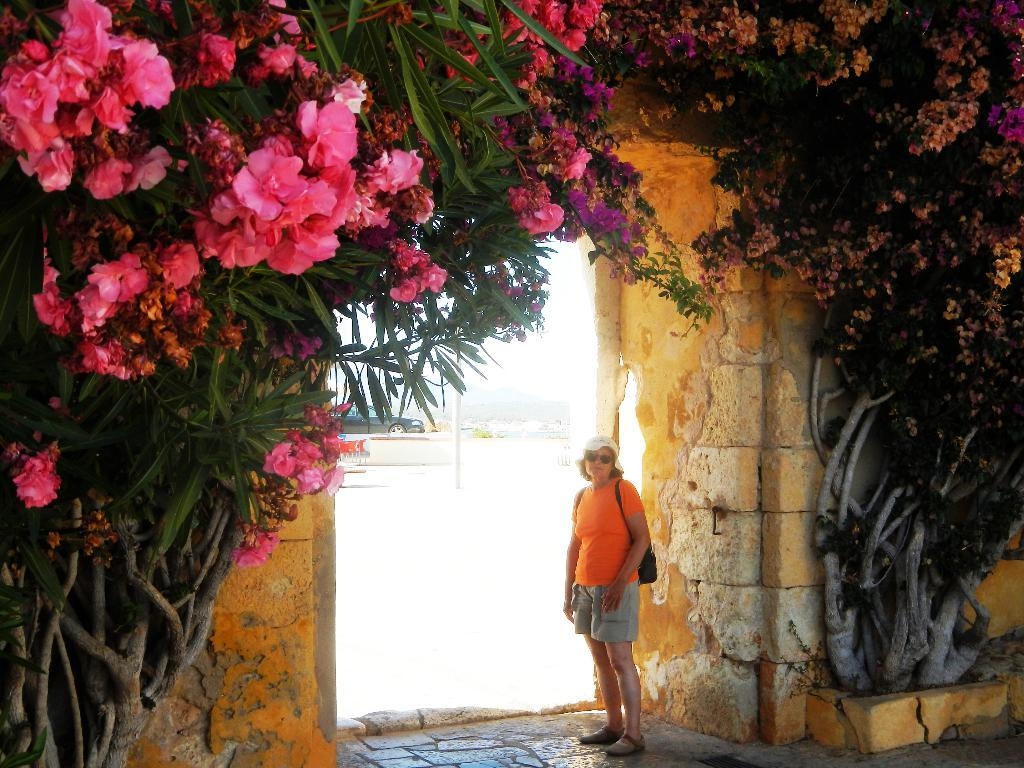What is the primary subject of the image? There is a woman in the image. What is the woman doing in the image? The woman is standing in the image. What is the woman carrying in the image? The woman is carrying a bag in the image. What type of vegetation can be seen in the image? There are flowers and trees in the image. What structures are present in the image? There is a wall and a pole in the image. What else can be seen in the background of the image? There is a car in the background of the image. What type of bird can be seen perched on the woman's shoulder in the image? There is no bird present in the image, let alone one perched on the woman's shoulder. 